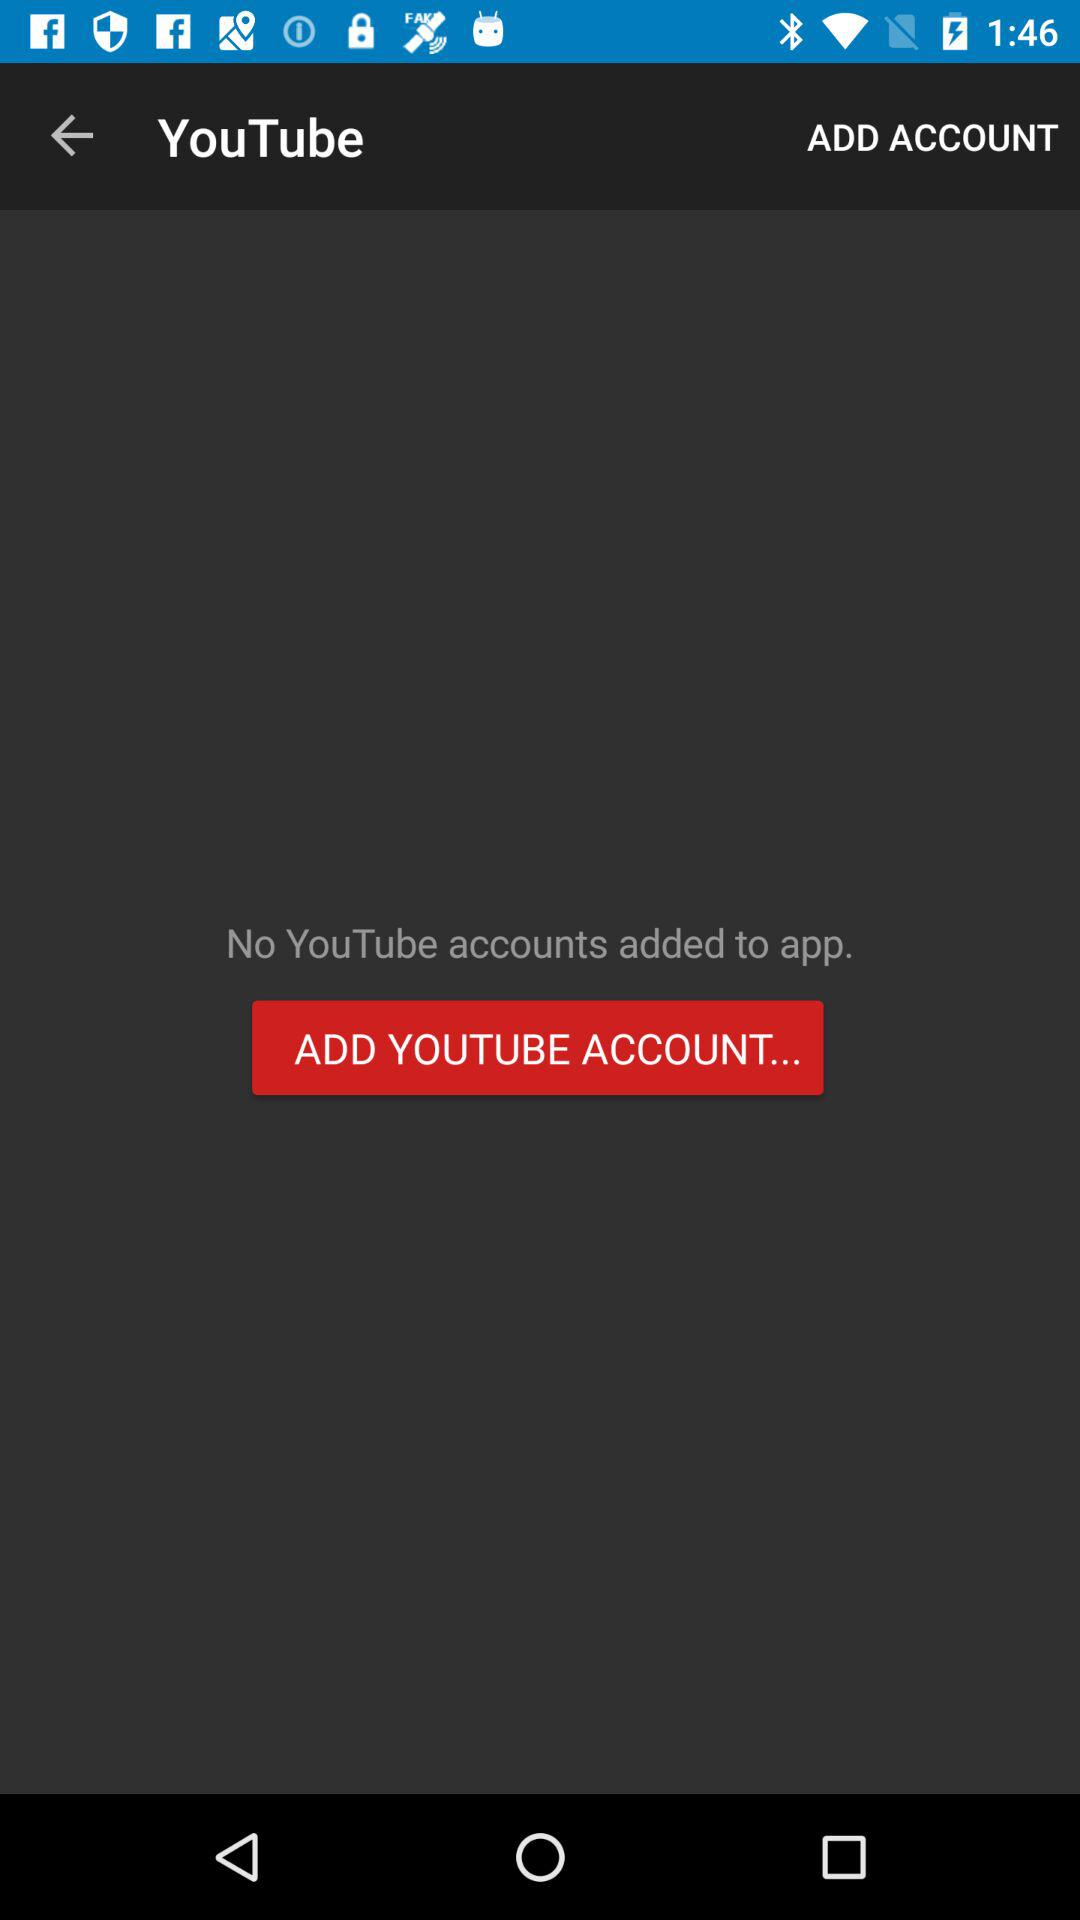How many YouTube accounts are there?
Answer the question using a single word or phrase. 0 